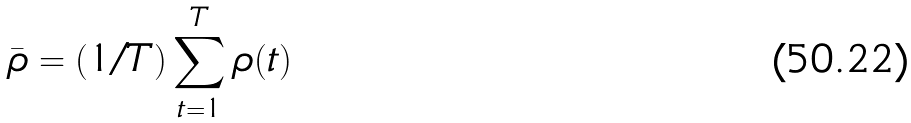<formula> <loc_0><loc_0><loc_500><loc_500>\bar { \rho } = ( 1 / T ) \sum _ { t = 1 } ^ { T } \rho ( t )</formula> 